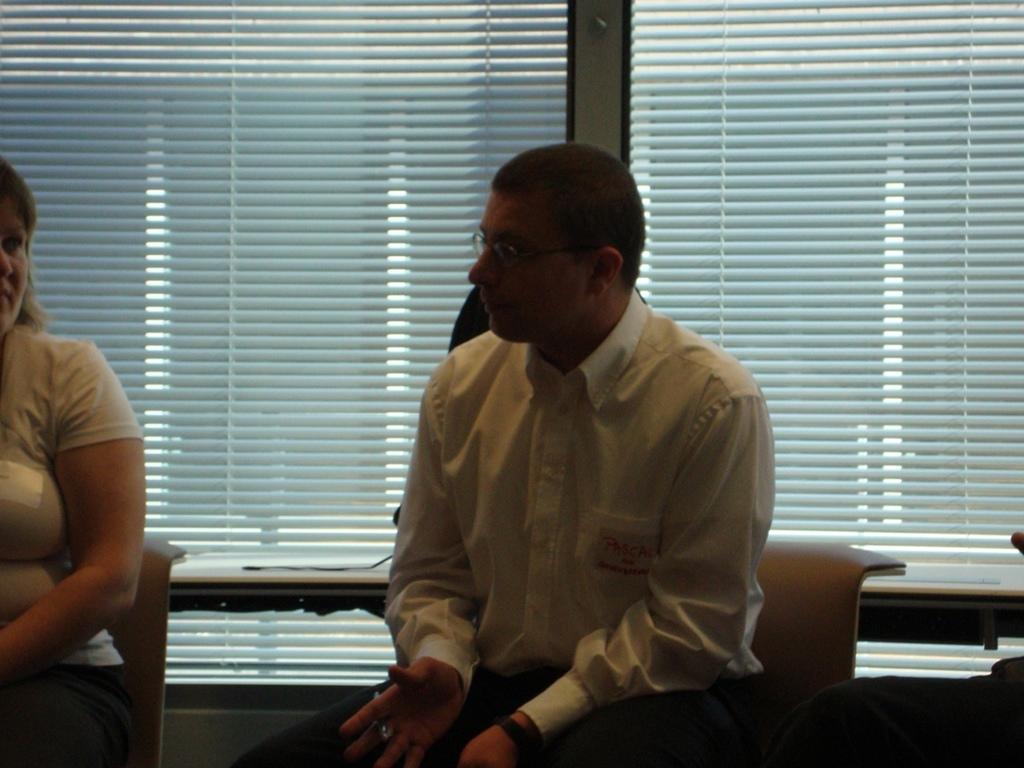How would you summarize this image in a sentence or two? In this image I can see two persons sitting, the person in front wearing white shirt, black pant. Background I can see a window. 